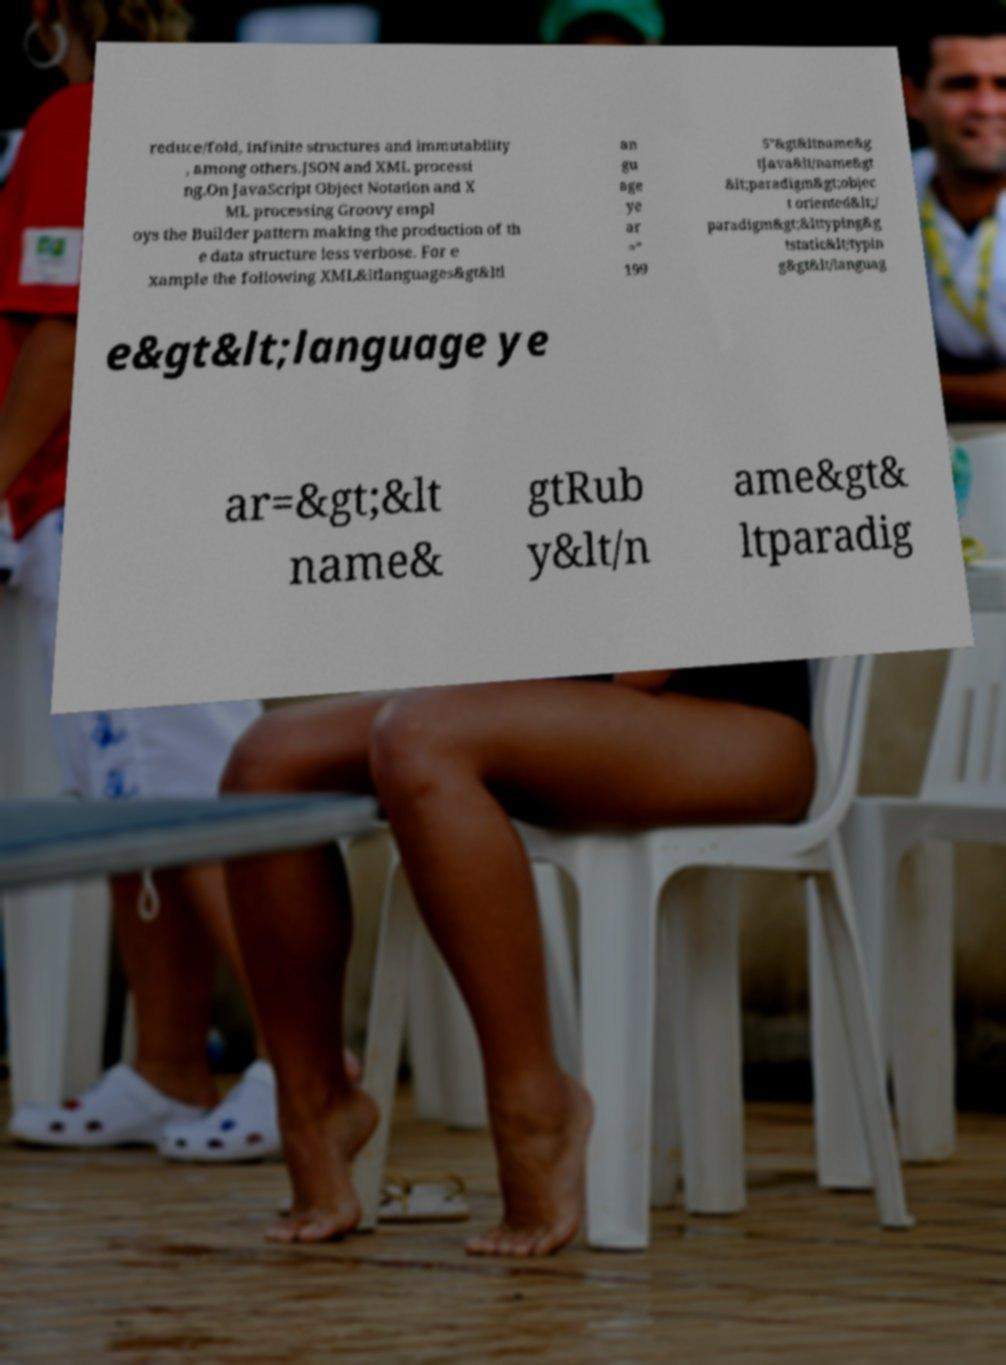Can you accurately transcribe the text from the provided image for me? reduce/fold, infinite structures and immutability , among others.JSON and XML processi ng.On JavaScript Object Notation and X ML processing Groovy empl oys the Builder pattern making the production of th e data structure less verbose. For e xample the following XML&ltlanguages&gt&ltl an gu age ye ar =" 199 5"&gt&ltname&g tJava&lt/name&gt &lt;paradigm&gt;objec t oriented&lt;/ paradigm&gt;&lttyping&g tstatic&lt/typin g&gt&lt/languag e&gt&lt;language ye ar=&gt;&lt name& gtRub y&lt/n ame&gt& ltparadig 